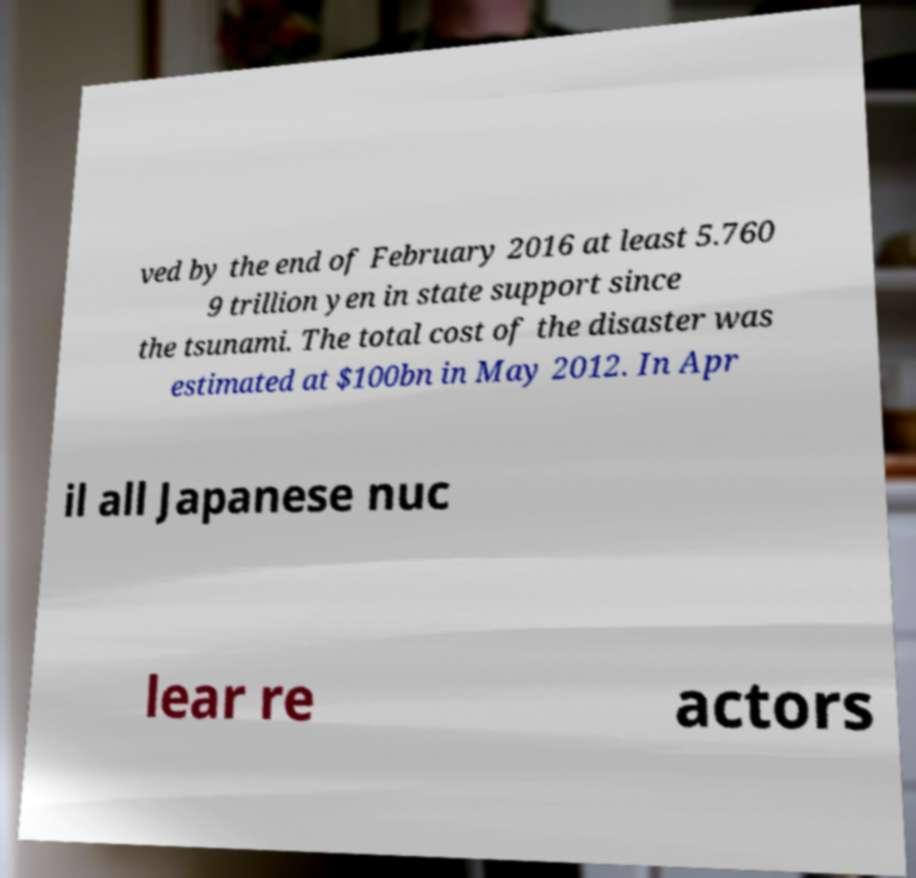Please identify and transcribe the text found in this image. ved by the end of February 2016 at least 5.760 9 trillion yen in state support since the tsunami. The total cost of the disaster was estimated at $100bn in May 2012. In Apr il all Japanese nuc lear re actors 